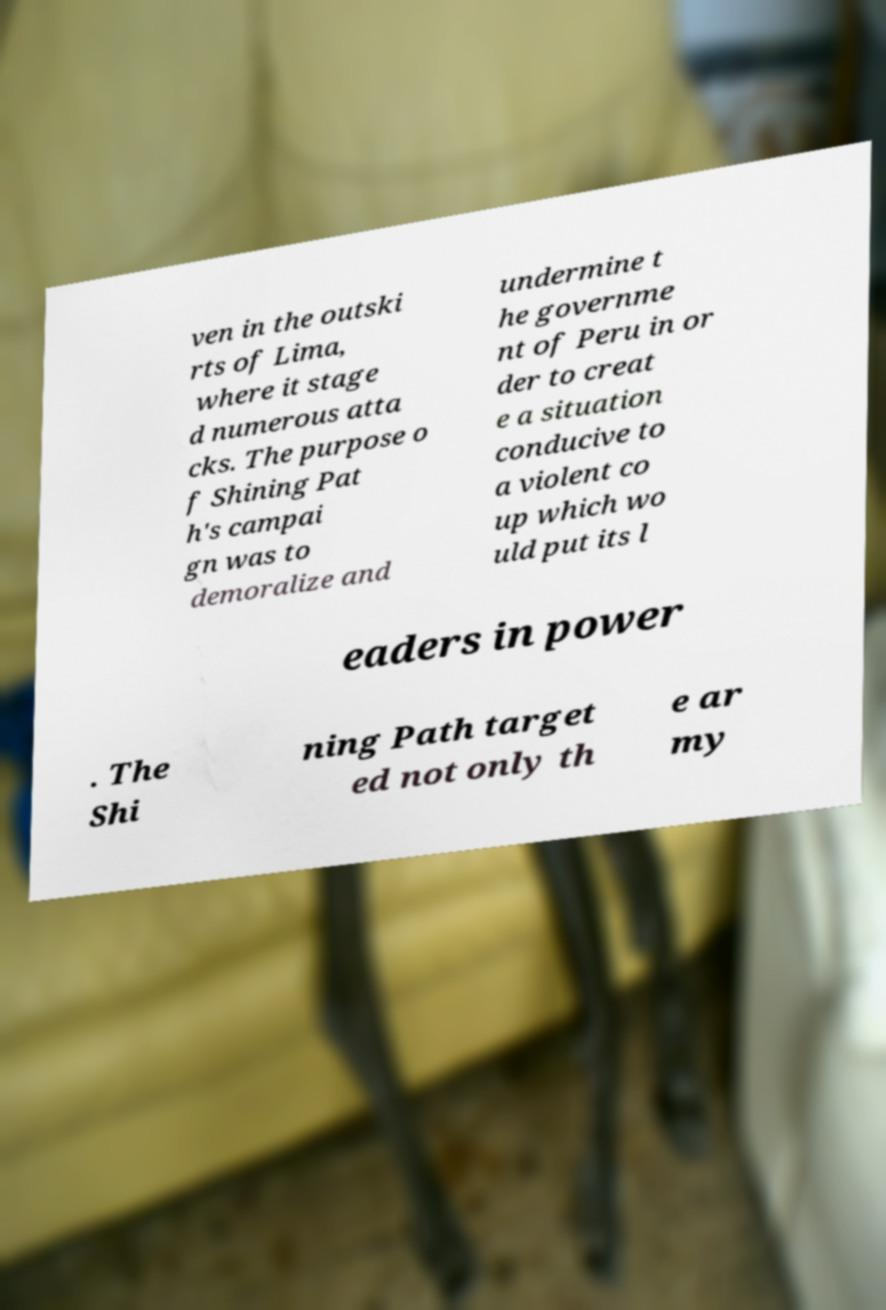There's text embedded in this image that I need extracted. Can you transcribe it verbatim? ven in the outski rts of Lima, where it stage d numerous atta cks. The purpose o f Shining Pat h's campai gn was to demoralize and undermine t he governme nt of Peru in or der to creat e a situation conducive to a violent co up which wo uld put its l eaders in power . The Shi ning Path target ed not only th e ar my 